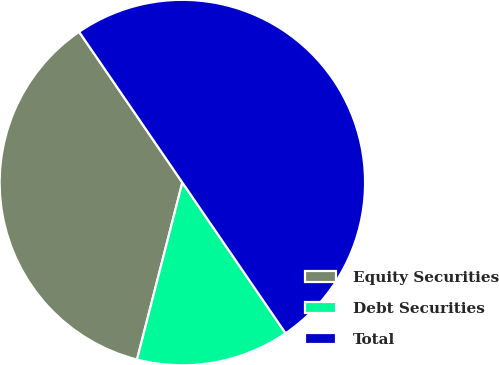Convert chart to OTSL. <chart><loc_0><loc_0><loc_500><loc_500><pie_chart><fcel>Equity Securities<fcel>Debt Securities<fcel>Total<nl><fcel>36.45%<fcel>13.55%<fcel>50.0%<nl></chart> 